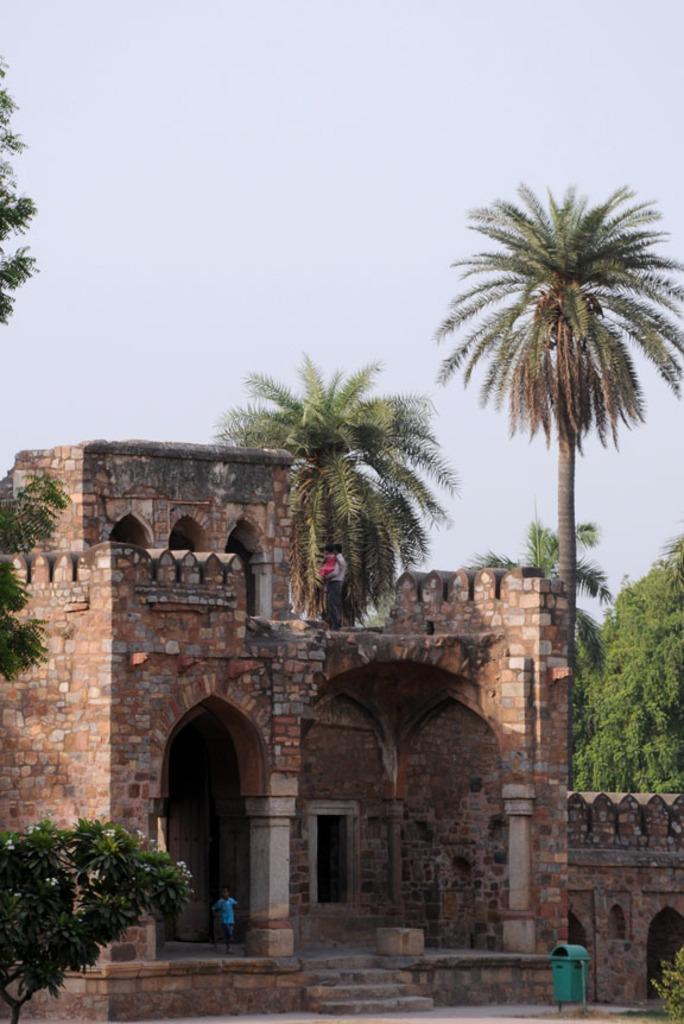Describe this image in one or two sentences. In this image there is a building. There are few people here. This is a dustbin. In the background there are trees. The sky is clear. 